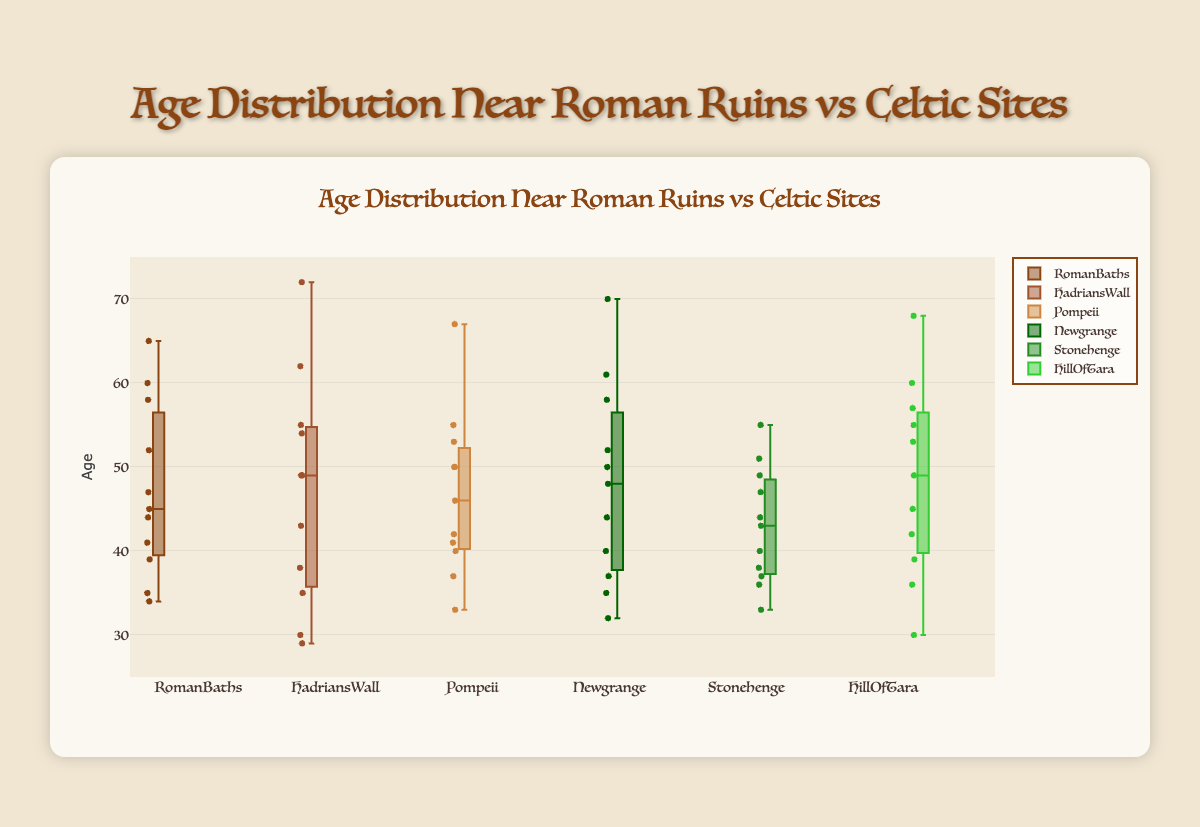What is the title of the plot? The title is displayed at the top center of the plot, in large text. It reads "Age Distribution Near Roman Ruins vs Celtic Sites".
Answer: Age Distribution Near Roman Ruins vs Celtic Sites Which site has the highest median age? To find the median age for each site, observe the line inside each box plot. The site with the highest line represents the highest median age.
Answer: Newgrange What is the age range for Hadrian's Wall? The age range is the difference between the upper and lower whiskers of the Hadrian's Wall box plot. The whiskers stretch from the minimum to the maximum values. On the Hadrian's Wall box plot, these ages are from 29 to 72.
Answer: 29 to 72 Which site has the smallest interquartile range (IQR)? The interquartile range can be determined by the height of the box in each plot. The IQR is the range between the first quartile (the bottom of the box) and the third quartile (the top of the box). The shortest box corresponds to the smallest IQR.
Answer: Pompeii What is the difference between the median ages of Stonehenge and Hill Of Tara? Identify the median lines in the box plots. For Stonehenge, the median is at 44. For Hill Of Tara, it's at 45. Compute their difference: 45 - 44.
Answer: 1 Which site exhibits the greatest spread in age distribution? The spread can be identified by the length of the whiskers on the box plots. The site with the longest whiskers has the greatest spread.
Answer: Hadrian's Wall Among Roman sites, which one has the highest lower quartile (Q1) age? Look at the bottom of the boxes for each Roman site to find the Q1 values. Select the highest among Roman Baths, Hadrian's Wall, and Pompeii.
Answer: Hadrian's Wall Is the median age at Hadrian's Wall higher than the average age of Pompeii? To compare, find the median for Hadrian's Wall (around 49) and the average for Pompeii (sum of ages divided by number of ages = (67+46+50+41+33+40+55+50+53+37+42)/11 = 47.45). Compare these two values.
Answer: Yes Which site has an older population on average: Stonehenge or Newgrange? Calculate the average age for both Stonehenge and Newgrange. For Stonehenge: (55+38+47+44+36+51+40+49+43+33+37)/11 = 42.18. For Newgrange: (70 + 52 + 48 + 40 + 35 + 58 + 61 + 44 + 37 + 32 + 50)/11 = 48.91. Compare the averages.
Answer: Newgrange Which location exhibits the least variation in age? Variation is indicated by the length of the box plot and whiskers. The site with the shortest overall span from the whiskers has the least variation.
Answer: Pompeii 